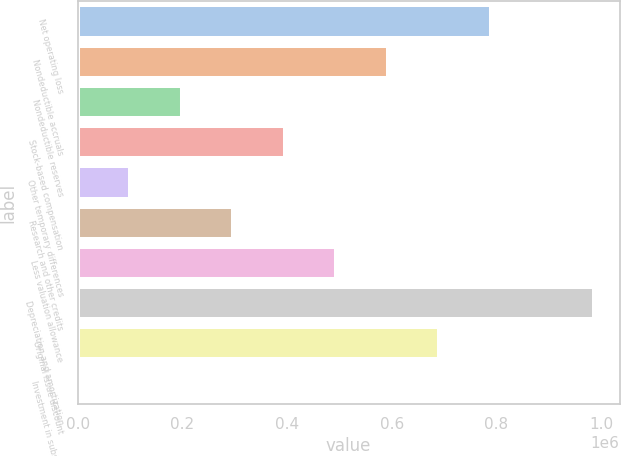<chart> <loc_0><loc_0><loc_500><loc_500><bar_chart><fcel>Net operating loss<fcel>Nondeductible accruals<fcel>Nondeductible reserves<fcel>Stock-based compensation<fcel>Other temporary differences<fcel>Research and other credits<fcel>Less valuation allowance<fcel>Depreciation and amortization<fcel>Original issue discount<fcel>Investment in subsidiary<nl><fcel>789094<fcel>592233<fcel>198510<fcel>395371<fcel>100080<fcel>296941<fcel>493802<fcel>985955<fcel>690663<fcel>1649<nl></chart> 